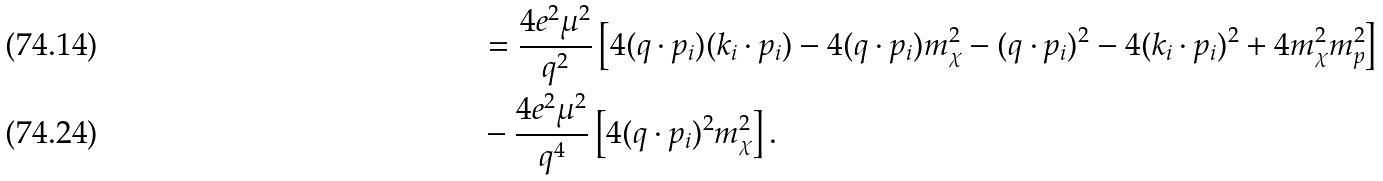<formula> <loc_0><loc_0><loc_500><loc_500>& = \frac { 4 e ^ { 2 } \mu ^ { 2 } } { q ^ { 2 } } \left [ 4 ( q \cdot p _ { i } ) ( k _ { i } \cdot p _ { i } ) - 4 ( q \cdot p _ { i } ) m _ { \chi } ^ { 2 } - ( q \cdot p _ { i } ) ^ { 2 } - 4 ( k _ { i } \cdot p _ { i } ) ^ { 2 } + 4 m _ { \chi } ^ { 2 } m _ { p } ^ { 2 } \right ] \\ & - \frac { 4 e ^ { 2 } \mu ^ { 2 } } { q ^ { 4 } } \left [ 4 ( q \cdot p _ { i } ) ^ { 2 } m _ { \chi } ^ { 2 } \right ] .</formula> 